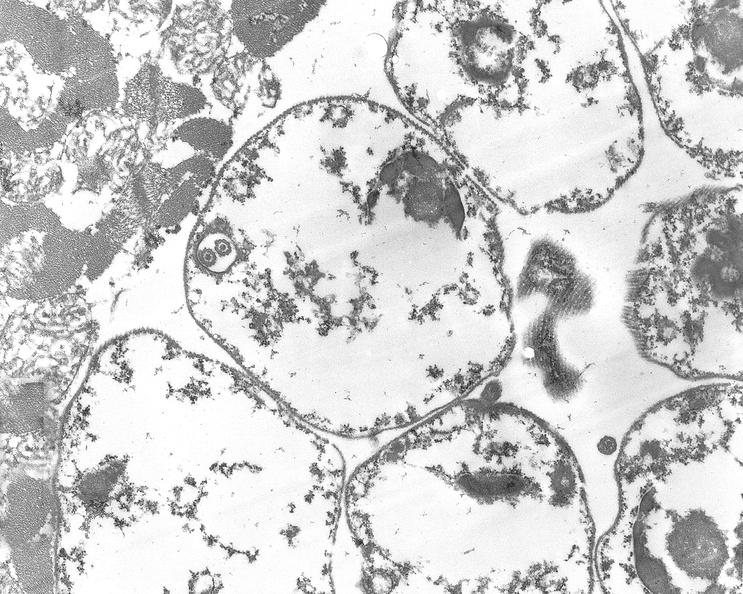what is present?
Answer the question using a single word or phrase. Cardiovascular 